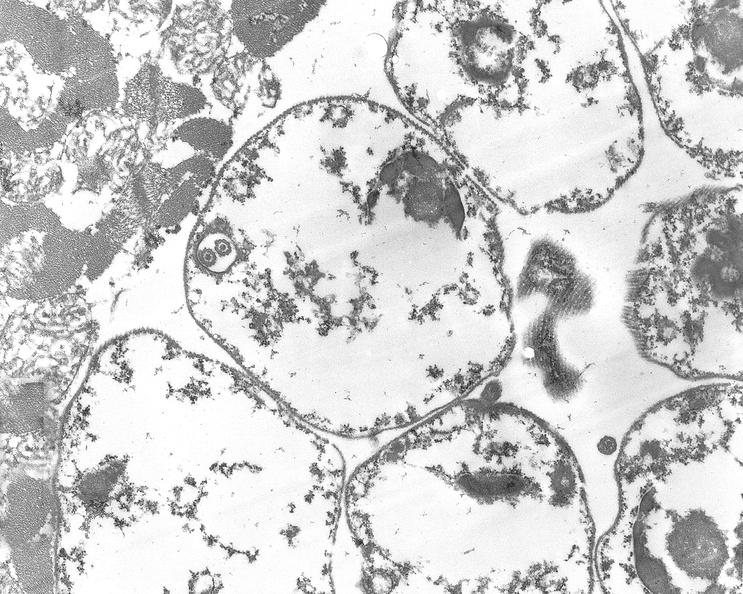what is present?
Answer the question using a single word or phrase. Cardiovascular 